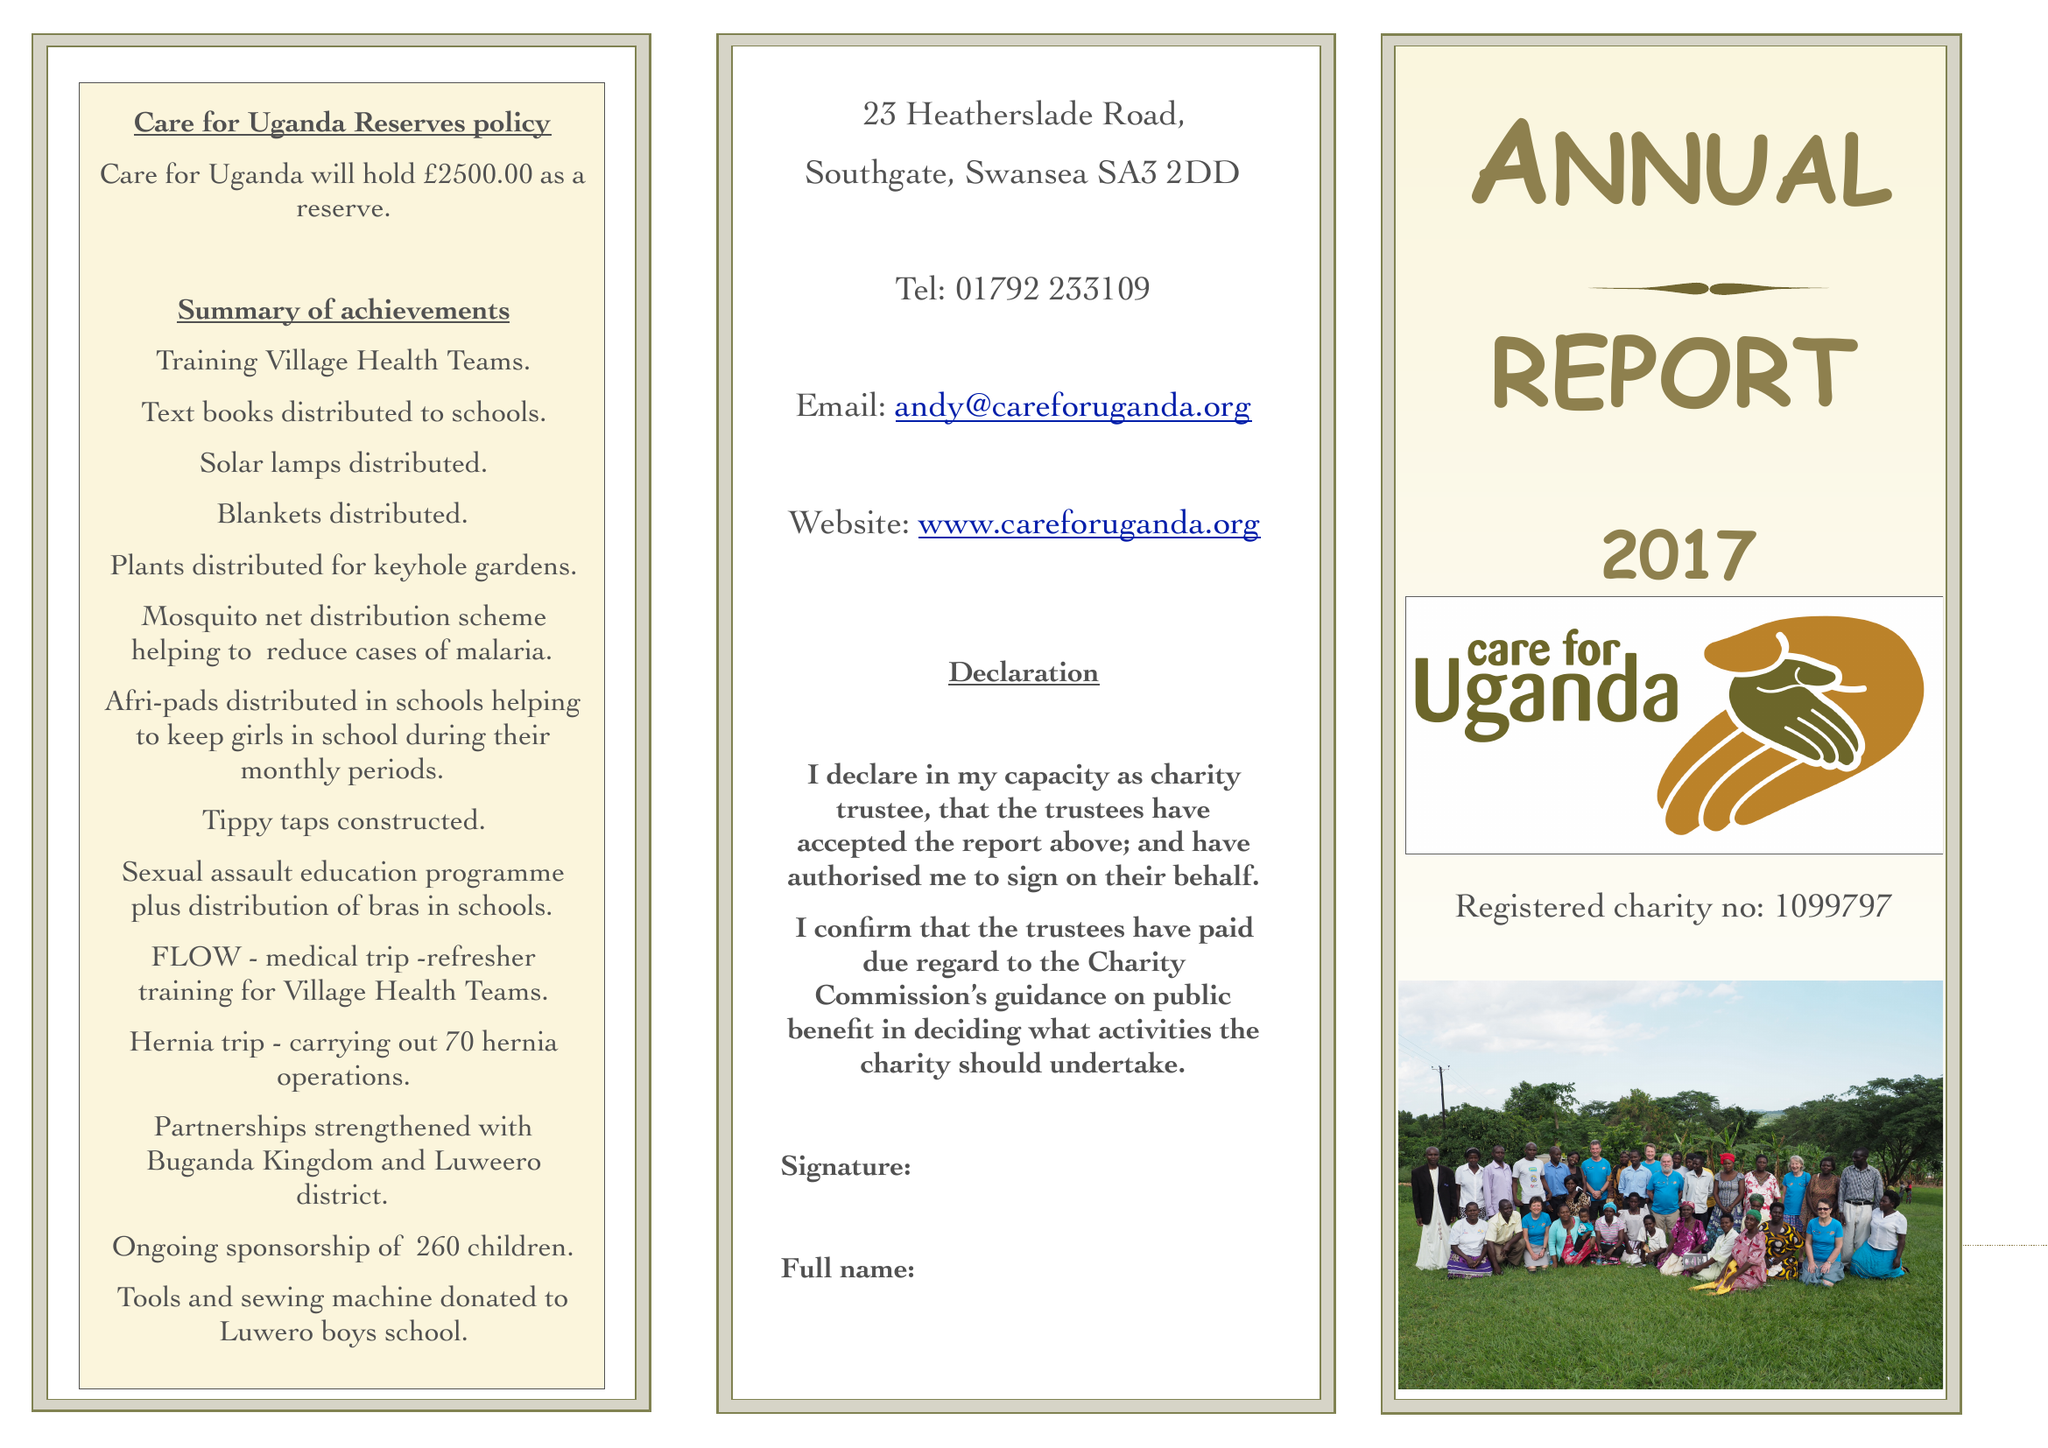What is the value for the income_annually_in_british_pounds?
Answer the question using a single word or phrase. 129642.00 